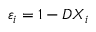Convert formula to latex. <formula><loc_0><loc_0><loc_500><loc_500>\varepsilon _ { i } = 1 - D X _ { i }</formula> 